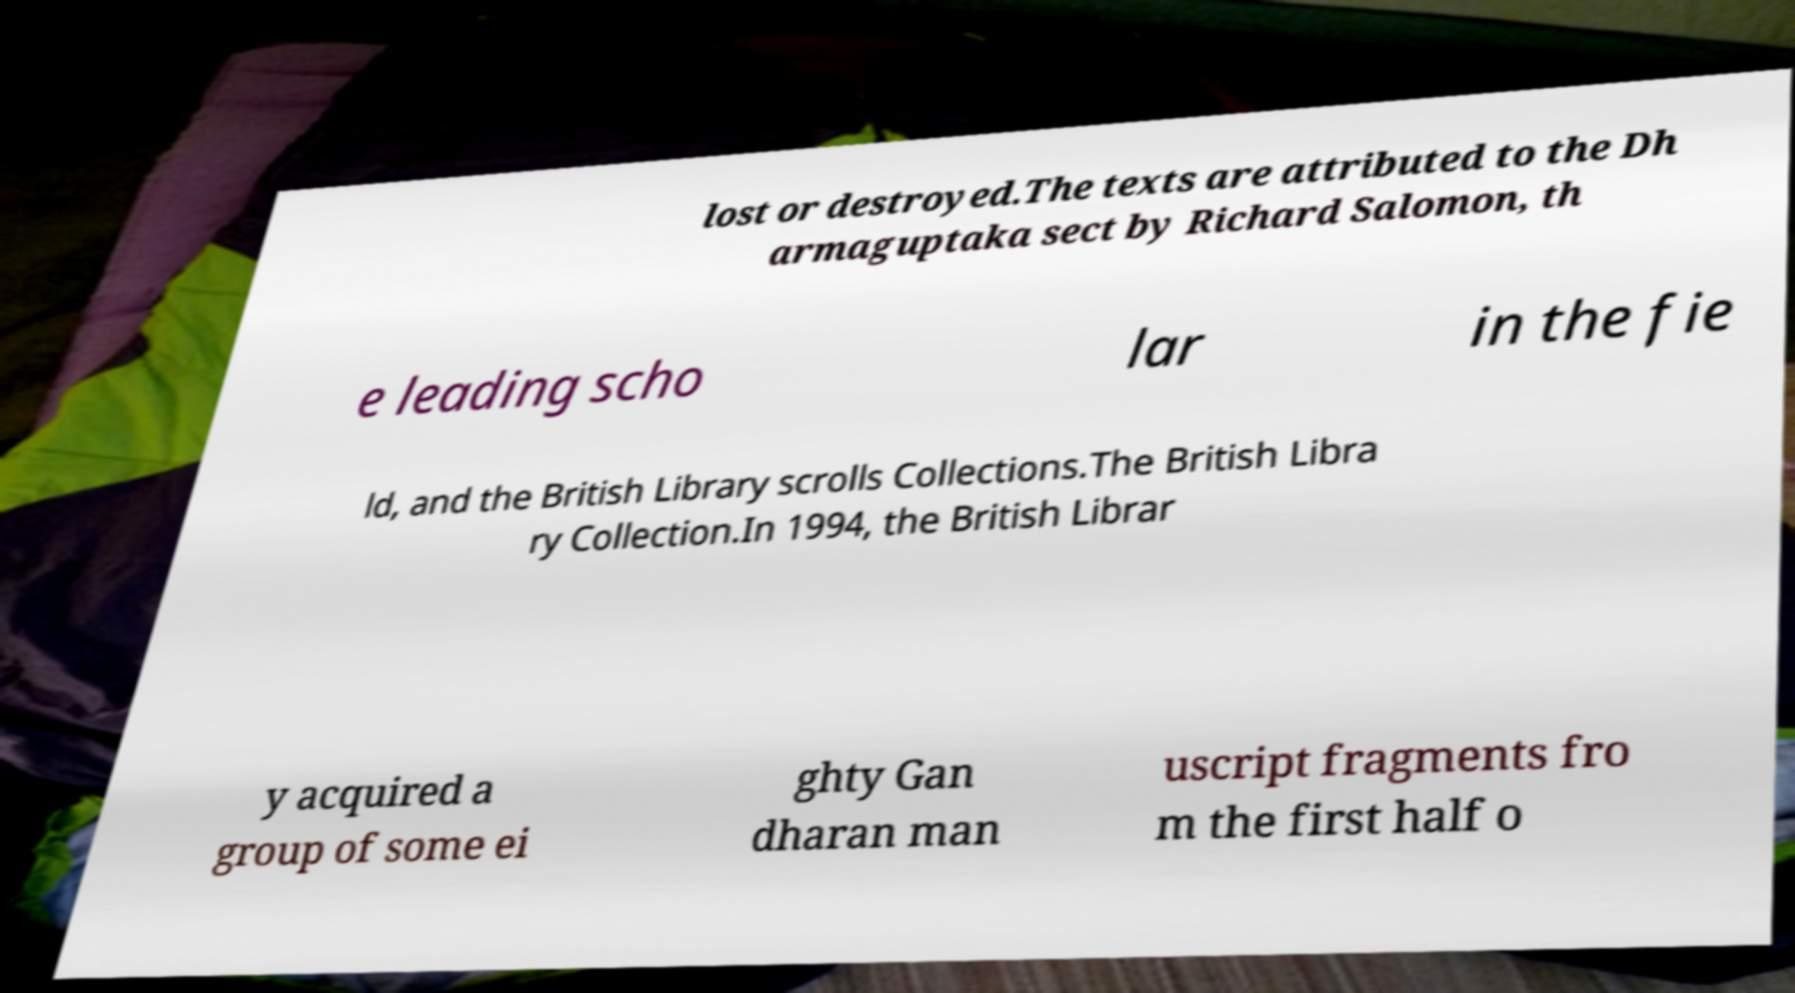There's text embedded in this image that I need extracted. Can you transcribe it verbatim? lost or destroyed.The texts are attributed to the Dh armaguptaka sect by Richard Salomon, th e leading scho lar in the fie ld, and the British Library scrolls Collections.The British Libra ry Collection.In 1994, the British Librar y acquired a group of some ei ghty Gan dharan man uscript fragments fro m the first half o 